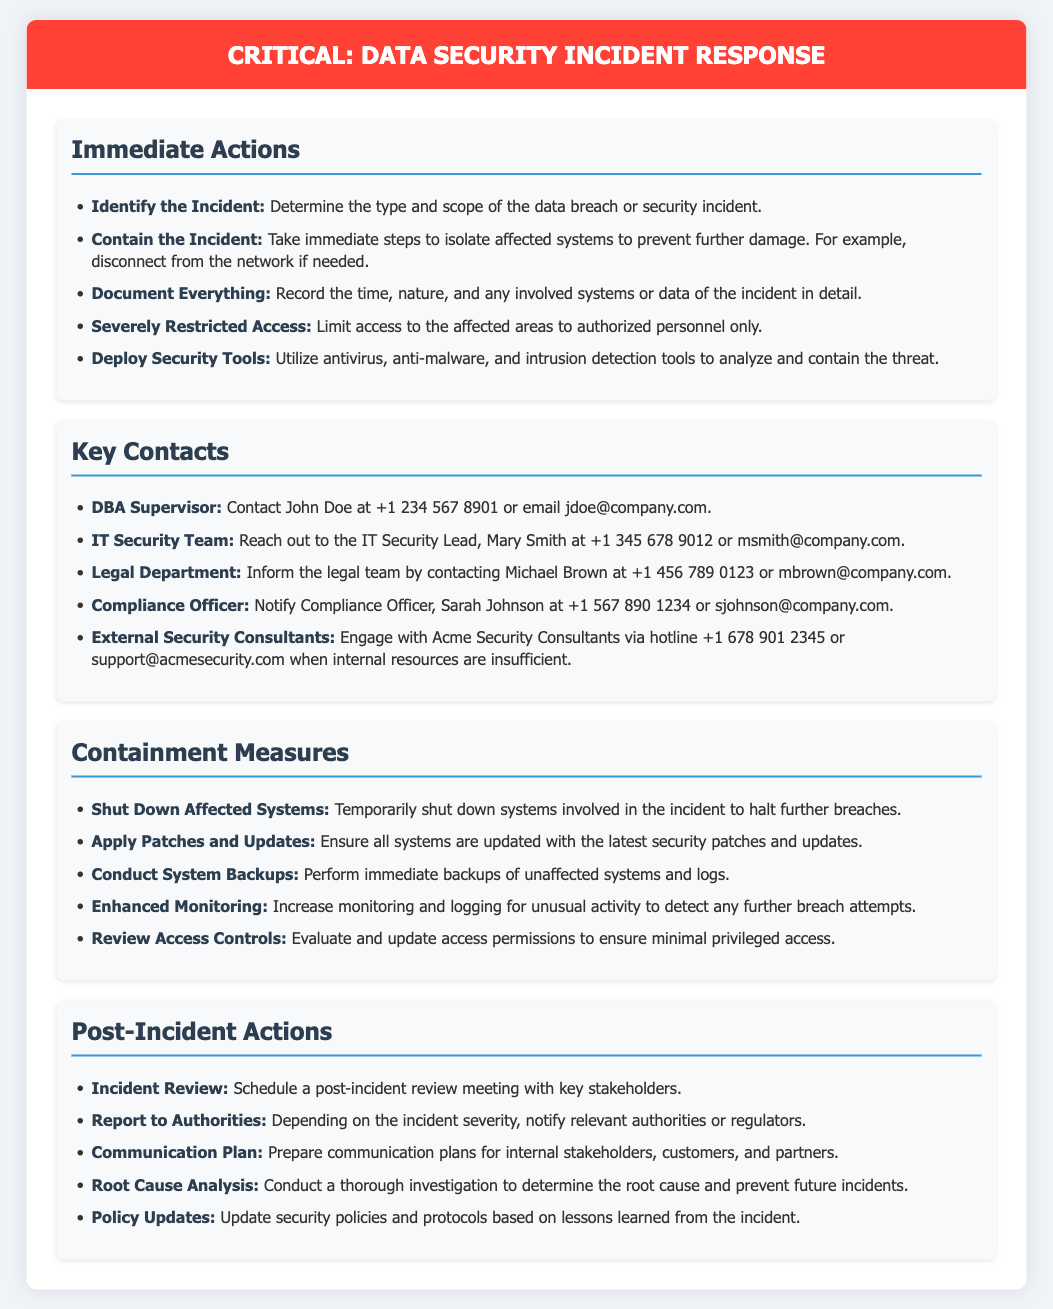What is the name of the DBA Supervisor? The document lists the DBA Supervisor as John Doe, who is a key contact for data security incidents.
Answer: John Doe What action should be taken to contain the incident? The document suggests taking immediate steps such as isolating affected systems and disconnecting from the network if necessary.
Answer: Contain the incident What is the contact number for the IT Security Team? The document provides the contact number for the IT Security Lead, Mary Smith.
Answer: +1 345 678 9012 How many steps are listed under Immediate Actions? The document includes five steps outlined for immediate actions to take during a data security incident.
Answer: Five What should be done immediately after a data breach? The document indicates that incident review is an important step following a data breach to assess the situation.
Answer: Incident Review Which section follows the Key Contacts section? The document organizes its content, with the "Containment Measures" section coming after "Key Contacts."
Answer: Containment Measures What role is responsible for notifying the legal team? The document describes the Legal Department as a contact point for notifying legal matters during an incident.
Answer: Legal Department What type of document is this? The document serves as a warning label specifically outlining protocols for data security incidents within an organization.
Answer: Warning label 